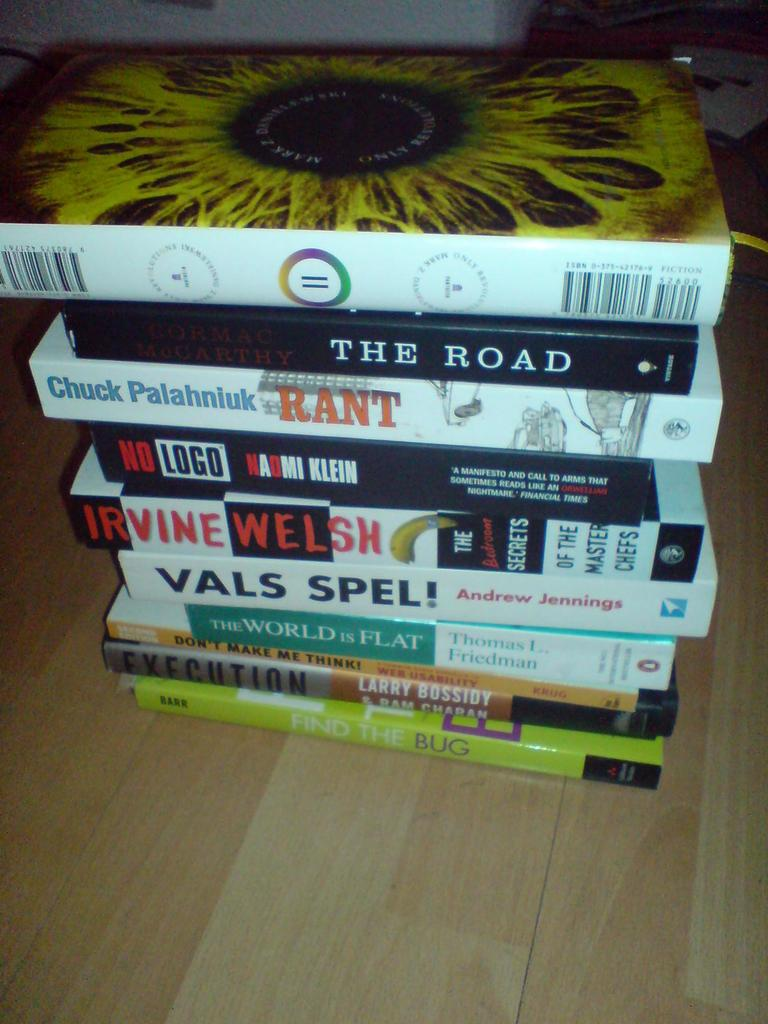<image>
Present a compact description of the photo's key features. A stack of books including Cormac McCarthy's The Road. 